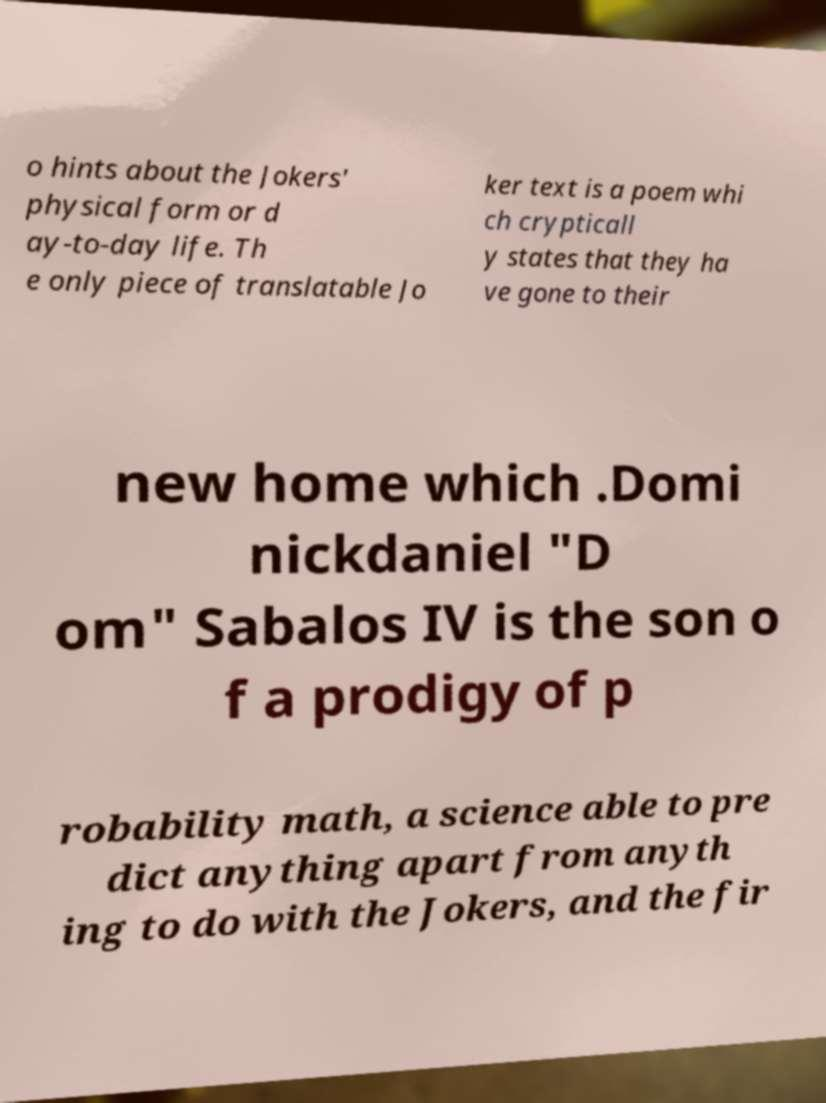Can you accurately transcribe the text from the provided image for me? o hints about the Jokers' physical form or d ay-to-day life. Th e only piece of translatable Jo ker text is a poem whi ch crypticall y states that they ha ve gone to their new home which .Domi nickdaniel "D om" Sabalos IV is the son o f a prodigy of p robability math, a science able to pre dict anything apart from anyth ing to do with the Jokers, and the fir 